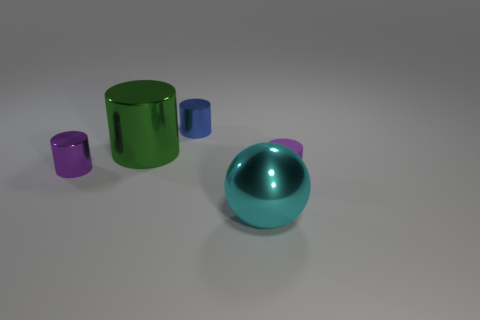Subtract all big green cylinders. How many cylinders are left? 3 Subtract all green cylinders. How many cylinders are left? 3 Subtract all cylinders. How many objects are left? 1 Subtract all green cubes. How many yellow cylinders are left? 0 Subtract all tiny cyan matte cylinders. Subtract all small metal objects. How many objects are left? 3 Add 4 large metallic objects. How many large metallic objects are left? 6 Add 5 green metallic cylinders. How many green metallic cylinders exist? 6 Add 5 shiny spheres. How many objects exist? 10 Subtract 1 green cylinders. How many objects are left? 4 Subtract 2 cylinders. How many cylinders are left? 2 